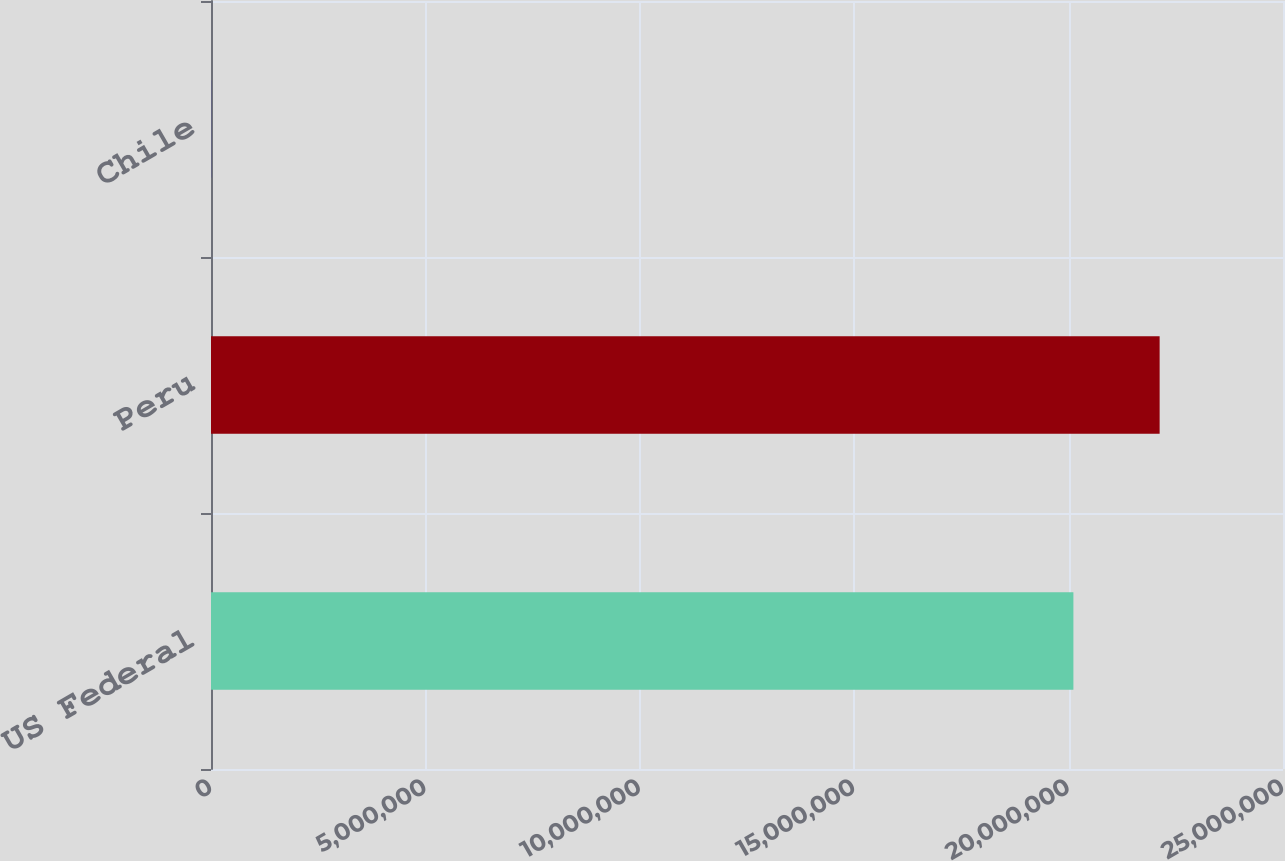Convert chart. <chart><loc_0><loc_0><loc_500><loc_500><bar_chart><fcel>US Federal<fcel>Peru<fcel>Chile<nl><fcel>2.0112e+07<fcel>2.2123e+07<fcel>2012<nl></chart> 